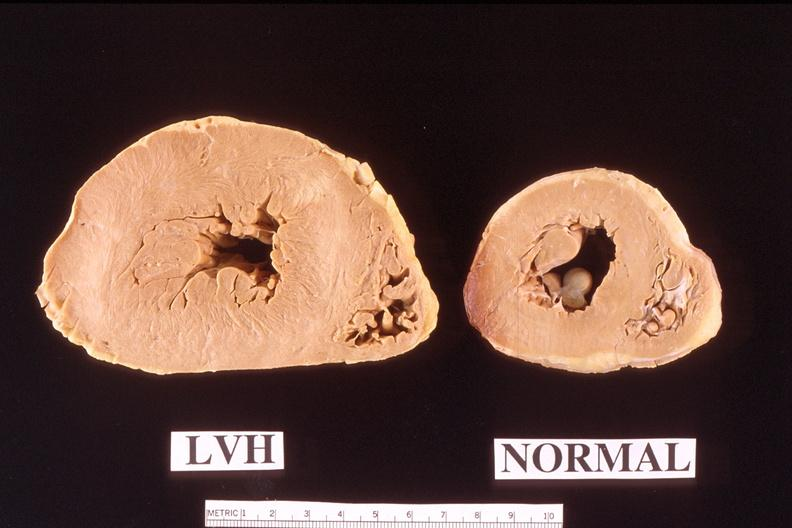where is this?
Answer the question using a single word or phrase. Heart 